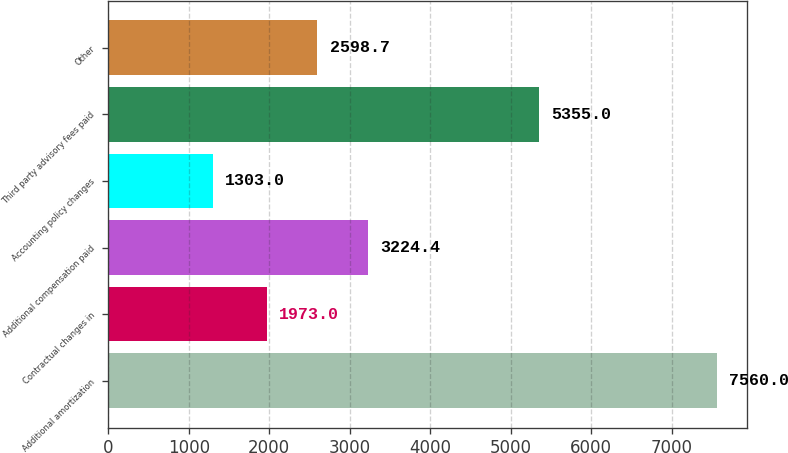<chart> <loc_0><loc_0><loc_500><loc_500><bar_chart><fcel>Additional amortization<fcel>Contractual changes in<fcel>Additional compensation paid<fcel>Accounting policy changes<fcel>Third party advisory fees paid<fcel>Other<nl><fcel>7560<fcel>1973<fcel>3224.4<fcel>1303<fcel>5355<fcel>2598.7<nl></chart> 